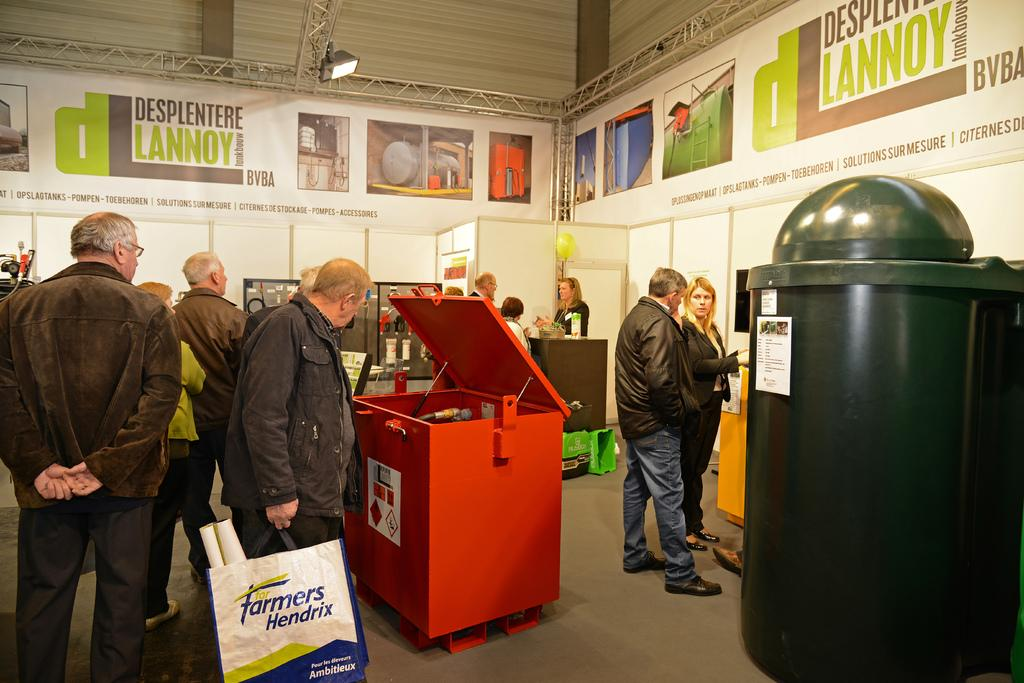<image>
Share a concise interpretation of the image provided. A man is holding a bag that says "farmers Hendrix" on it. 